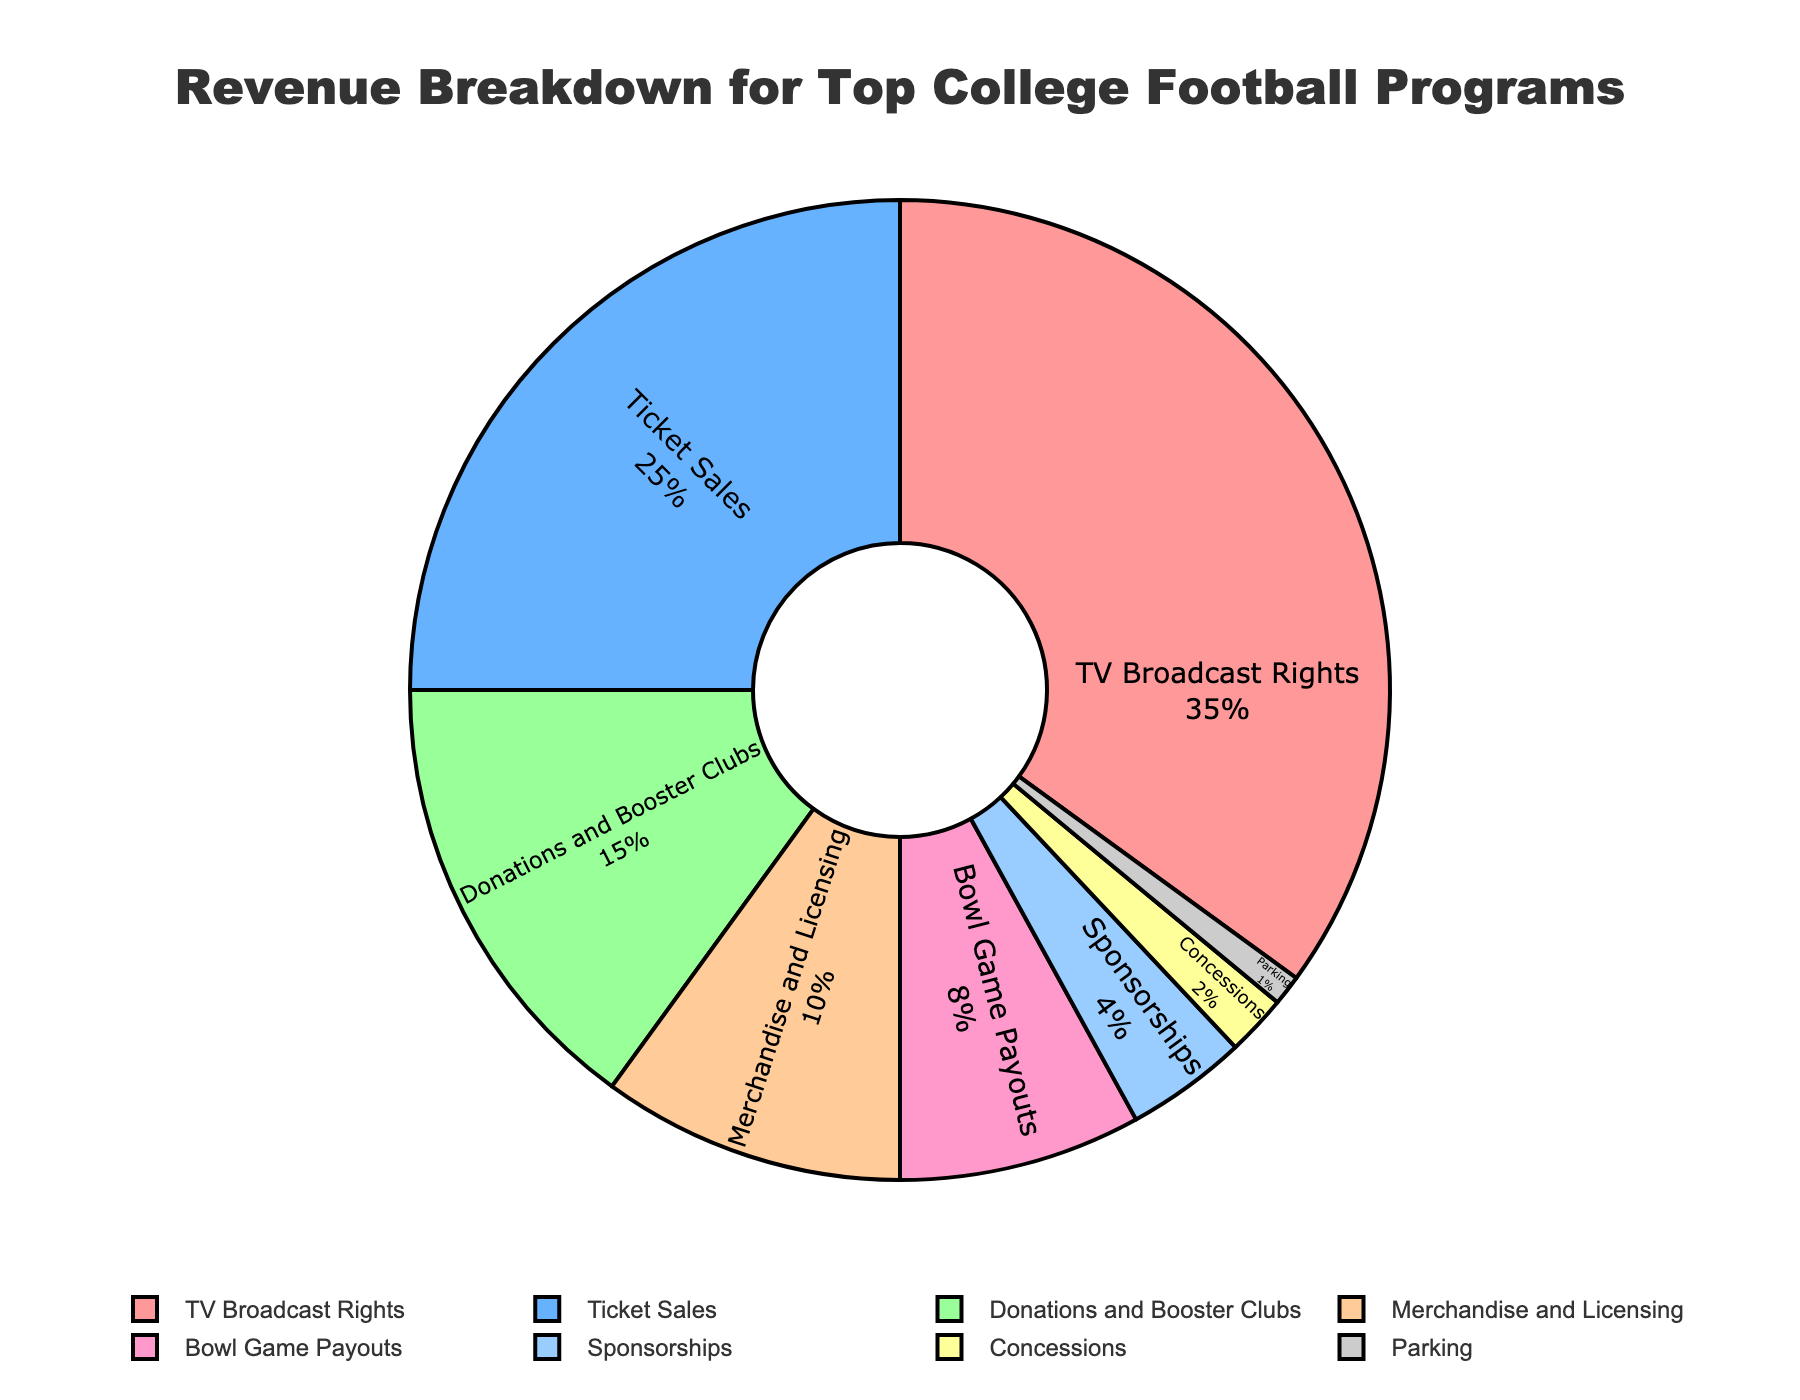Which revenue source contributes the most to the total revenue? The slice labeled "TV Broadcast Rights" appears to be the largest segment in the pie chart, indicating it contributes the most to the total revenue with a percentage of 35%.
Answer: TV Broadcast Rights What's the total percentage of revenue contributed by Merchandise and Licensing and Concessions combined? Adding the percentage of Merchandise and Licensing (10%) with that of Concessions (2%) gives a total of, 10% + 2% = 12%.
Answer: 12% Which revenue source contributes less: Sponsorships or Parking? The slice labeled "Parking" is smaller than the slice labeled "Sponsorships" in the pie chart. Parking contributes 1%, while Sponsorships contribute 4%.
Answer: Parking What is the percentage difference between Donations and Booster Clubs and Ticket Sales? The percentage for Ticket Sales is 25%, while for Donations and Booster Clubs it is 15%. The difference is 25% - 15% = 10%.
Answer: 10% Which revenue source shares the same color as Sponsorships? Both "TV Broadcast Rights" and "Sponsorships" are marked with red colors, indicating they share the same color.
Answer: TV Broadcast Rights How much higher is the contribution of Bowl Game Payouts compared to Parking? Bowl Game Payouts contribute 8%, and Parking contributes 1%. The difference is 8% - 1% = 7%.
Answer: 7% What combined percentage of revenue sources is contributed by Concessions, Parking, and Sponsorships? Adding the percentages: Concessions (2%), Parking (1%), and Sponsorships (4%) gives 2% + 1% + 4% = 7%.
Answer: 7% List the revenue sources in descending order based on their contribution. By examining the sizes of the slices and their corresponding percentages, we list them as: TV Broadcast Rights (35%), Ticket Sales (25%), Donations and Booster Clubs (15%), Merchandise and Licensing (10%), Bowl Game Payouts (8%), Sponsorships (4%), Concessions (2%), Parking (1%).
Answer: TV Broadcast Rights, Ticket Sales, Donations and Booster Clubs, Merchandise and Licensing, Bowl Game Payouts, Sponsorships, Concessions, Parking If TV Broadcast Rights and Ticket Sales were combined into a single category, what would be its percentage of the total revenue? Combining TV Broadcast Rights (35%) and Ticket Sales (25%), the new category would be 35% + 25% = 60% of the total revenue.
Answer: 60% 